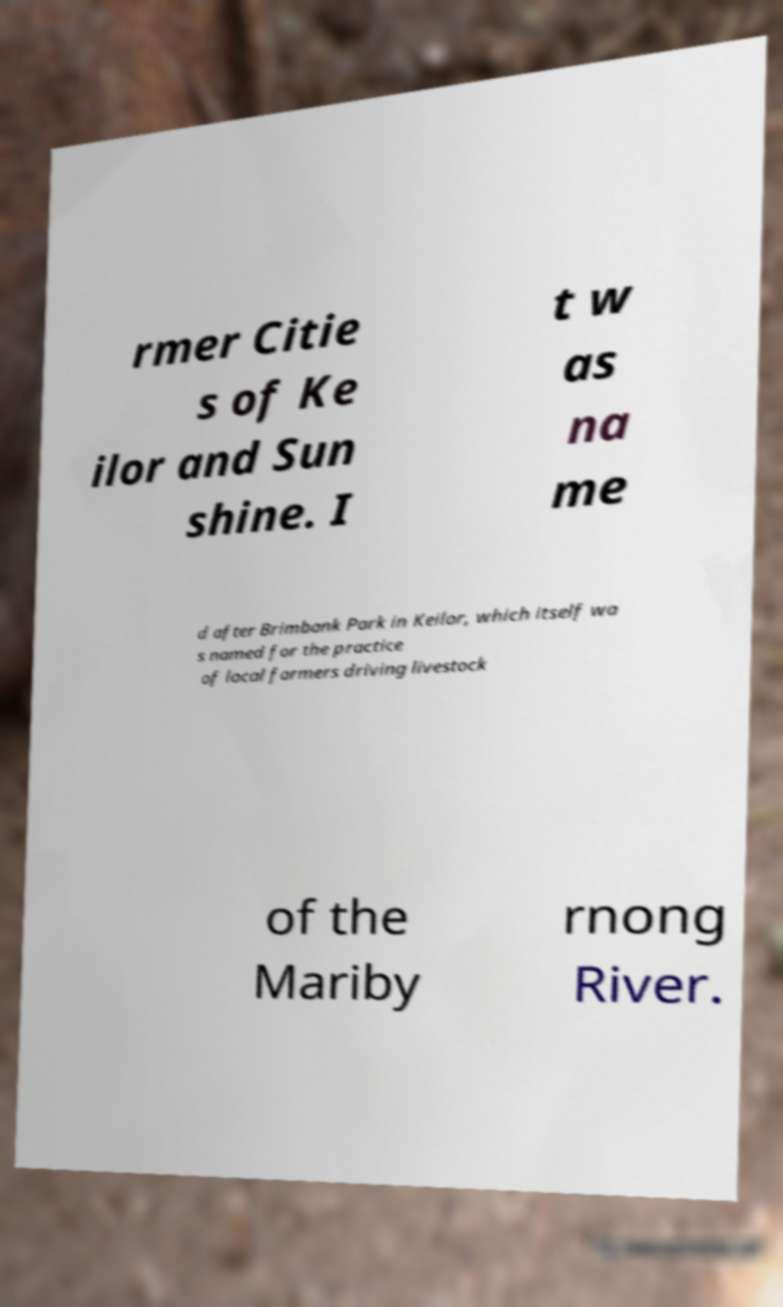Can you read and provide the text displayed in the image?This photo seems to have some interesting text. Can you extract and type it out for me? rmer Citie s of Ke ilor and Sun shine. I t w as na me d after Brimbank Park in Keilor, which itself wa s named for the practice of local farmers driving livestock of the Mariby rnong River. 